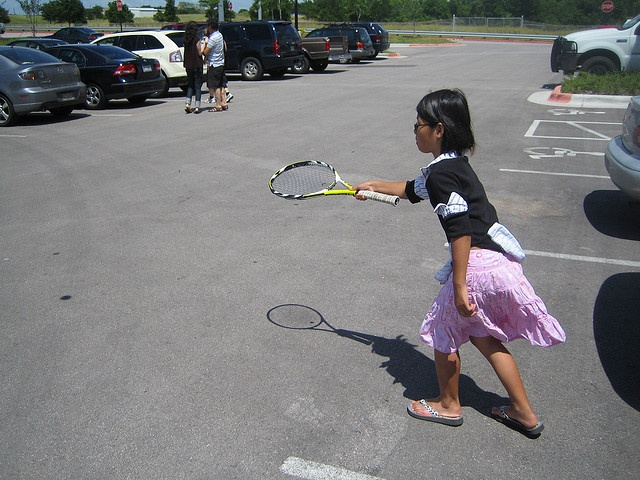Describe the objects in this image and their specific colors. I can see people in gray, black, purple, lavender, and brown tones, car in gray, black, and darkblue tones, car in gray, black, navy, and darkblue tones, truck in gray, black, lightgray, and lightblue tones, and car in gray, black, navy, and darkgray tones in this image. 